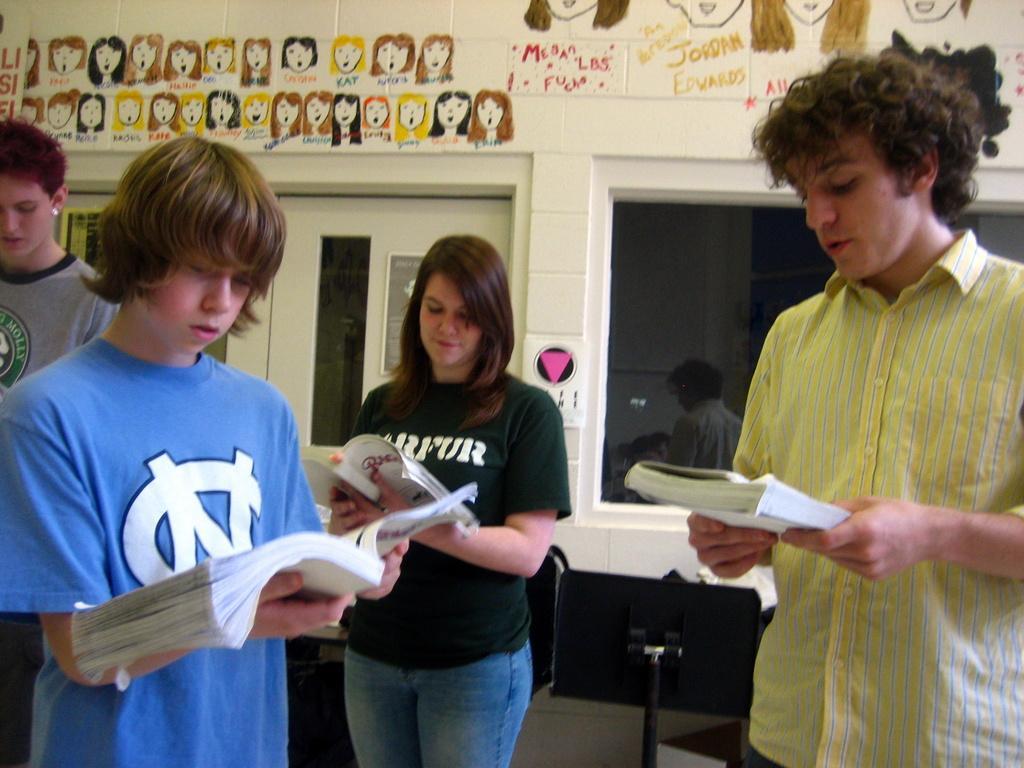Describe this image in one or two sentences. In the picture we can see four people are standing on the floor and holding books and learning something and behind them we can see a wall with door and glass window and on the top of the window we can see some paintings on the wall. 